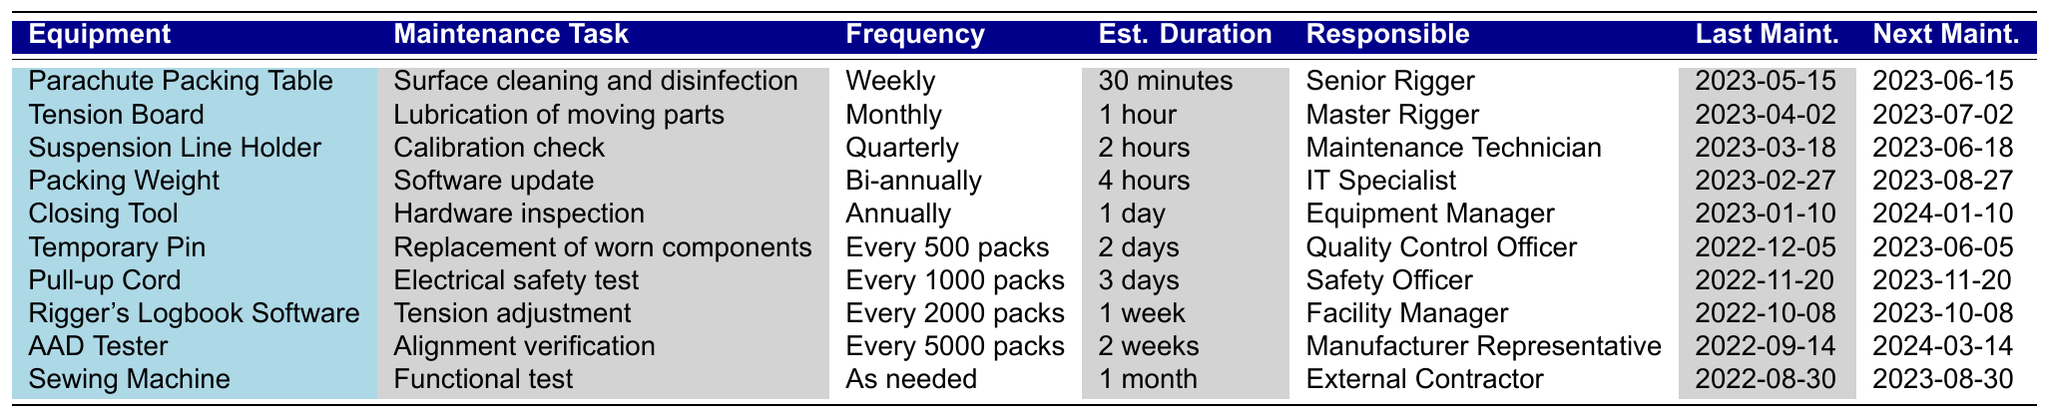What maintenance task is performed on the Tension Board? The table shows that the Tension Board requires "Lubrication of moving parts" as the maintenance task.
Answer: Lubrication of moving parts When is the next scheduled maintenance for the Closing Tool? According to the table, the next scheduled maintenance for the Closing Tool is on "2024-01-10."
Answer: 2024-01-10 Which equipment has the longest estimated maintenance duration and what is that duration? The table indicates that the Sewing Machine has the longest estimated duration of "1 month" since its maintenance is based on "As needed."
Answer: 1 month How often is the Rigger's Logbook Software scheduled for maintenance? The table specifies that the Rigger's Logbook Software requires maintenance "Every 2000 packs."
Answer: Every 2000 packs Is the last maintenance date for the Packing Weight before or after May 2023? The last maintenance date for the Packing Weight is "2023-02-27," which is before May 2023.
Answer: Before What is the maintenance frequency for the Pull-up Cord compared to the Tension Board? The Pull-up Cord frequency is "Every 1000 packs," which is less frequent than the Tension Board's "Monthly" schedule.
Answer: Less frequent Calculate the total estimated maintenance time for all pieces of equipment that have a scheduled maintenance frequency of "Quarterly." The only piece of equipment with a "Quarterly" maintenance frequency is the Suspension Line Holder, with an estimated duration of 2 hours. So, the total is 2 hours.
Answer: 2 hours Which responsible person is assigned to the maintenance of the Packing Weight? The table indicates that the IT Specialist is responsible for the maintenance of the Packing Weight.
Answer: IT Specialist Is there any equipment that requires maintenance every 5,000 packs, and if so, what is that equipment? Yes, the AAD Tester requires maintenance every 5000 packs, according to the table.
Answer: AAD Tester How many pieces of equipment are scheduled for maintenance on a weekly basis? The table indicates that only one piece of equipment, the Parachute Packing Table, is scheduled for maintenance weekly.
Answer: 1 